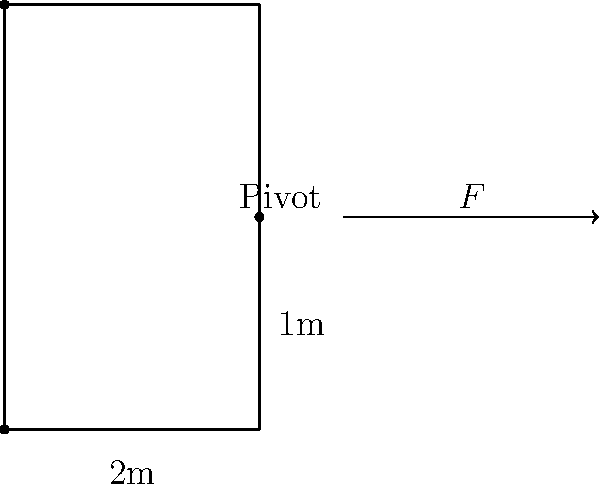A police tactical team is using a battering ram to breach a door during an operation. The door is 2 meters tall, and the ram strikes the door 1 meter from the hinged edge. If the team applies a force of 800 N to the ram, what is the magnitude of the torque applied to the door about its hinges? To solve this problem, we need to understand the principle of torque and how it relates to the force applied and the distance from the pivot point. Let's break it down step-by-step:

1) Torque is defined as the cross product of the force vector and the position vector:
   $$\tau = \vec{r} \times \vec{F}$$

2) In scalar form, for a force perpendicular to the position vector, this becomes:
   $$\tau = r F \sin\theta$$
   where $\theta$ is the angle between $\vec{r}$ and $\vec{F}$.

3) In this case, the force is perpendicular to the door, so $\sin\theta = 1$.

4) The distance from the hinge (pivot point) to the point of impact is 1 meter.

5) The applied force is 800 N.

6) Plugging these values into our equation:
   $$\tau = (1 \text{ m})(800 \text{ N})$$

7) Calculate the result:
   $$\tau = 800 \text{ N}\cdot\text{m}$$

Therefore, the magnitude of the torque applied to the door about its hinges is 800 N⋅m.
Answer: 800 N⋅m 